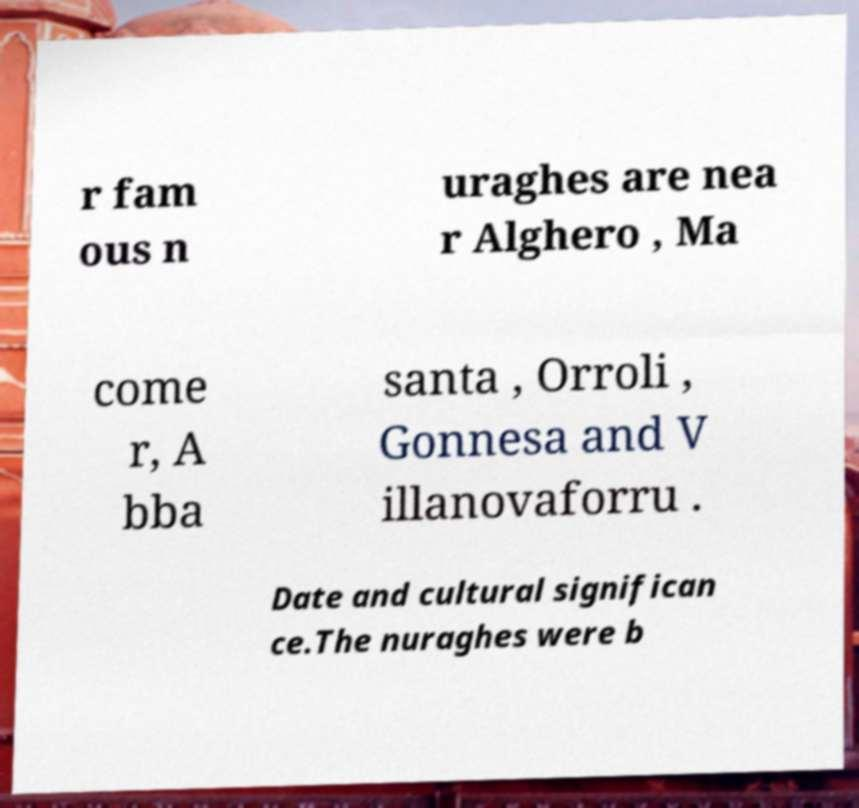There's text embedded in this image that I need extracted. Can you transcribe it verbatim? r fam ous n uraghes are nea r Alghero , Ma come r, A bba santa , Orroli , Gonnesa and V illanovaforru . Date and cultural significan ce.The nuraghes were b 